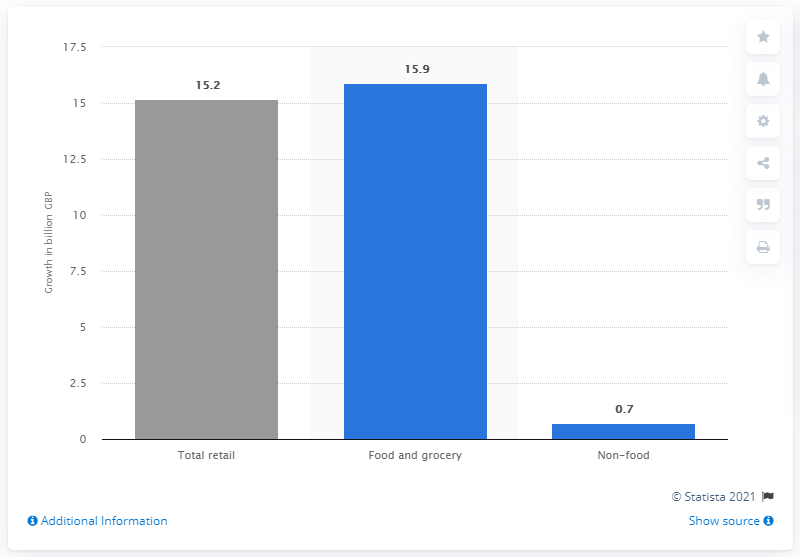Outline some significant characteristics in this image. According to estimates, the food and grocery retail sector in the UK was expected to grow by 15.9% from 2009 to 2013. 